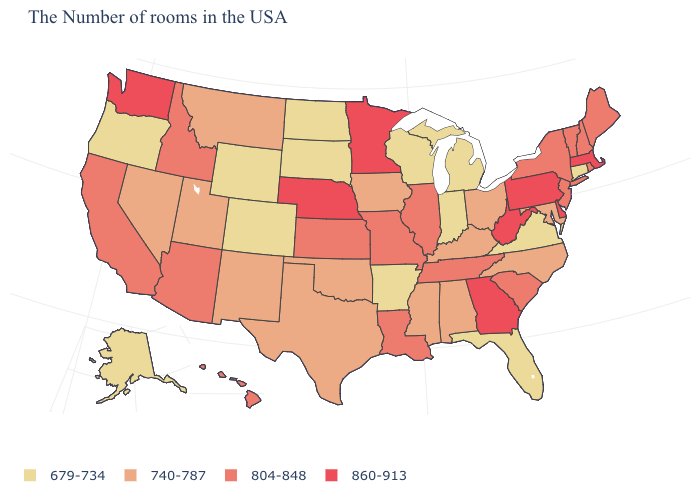Does South Carolina have a lower value than Florida?
Be succinct. No. Name the states that have a value in the range 860-913?
Be succinct. Massachusetts, Delaware, Pennsylvania, West Virginia, Georgia, Minnesota, Nebraska, Washington. What is the value of California?
Short answer required. 804-848. What is the value of West Virginia?
Short answer required. 860-913. What is the value of Wyoming?
Quick response, please. 679-734. What is the lowest value in the USA?
Be succinct. 679-734. What is the value of Michigan?
Give a very brief answer. 679-734. Does Michigan have a lower value than North Dakota?
Write a very short answer. No. What is the value of Colorado?
Quick response, please. 679-734. Name the states that have a value in the range 679-734?
Short answer required. Connecticut, Virginia, Florida, Michigan, Indiana, Wisconsin, Arkansas, South Dakota, North Dakota, Wyoming, Colorado, Oregon, Alaska. How many symbols are there in the legend?
Concise answer only. 4. What is the value of Missouri?
Answer briefly. 804-848. What is the value of Colorado?
Write a very short answer. 679-734. What is the lowest value in the USA?
Answer briefly. 679-734. What is the lowest value in states that border Texas?
Quick response, please. 679-734. 